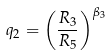<formula> <loc_0><loc_0><loc_500><loc_500>q _ { 2 } = \left ( \frac { R _ { 3 } } { R _ { 5 } } \right ) ^ { \beta _ { 3 } }</formula> 